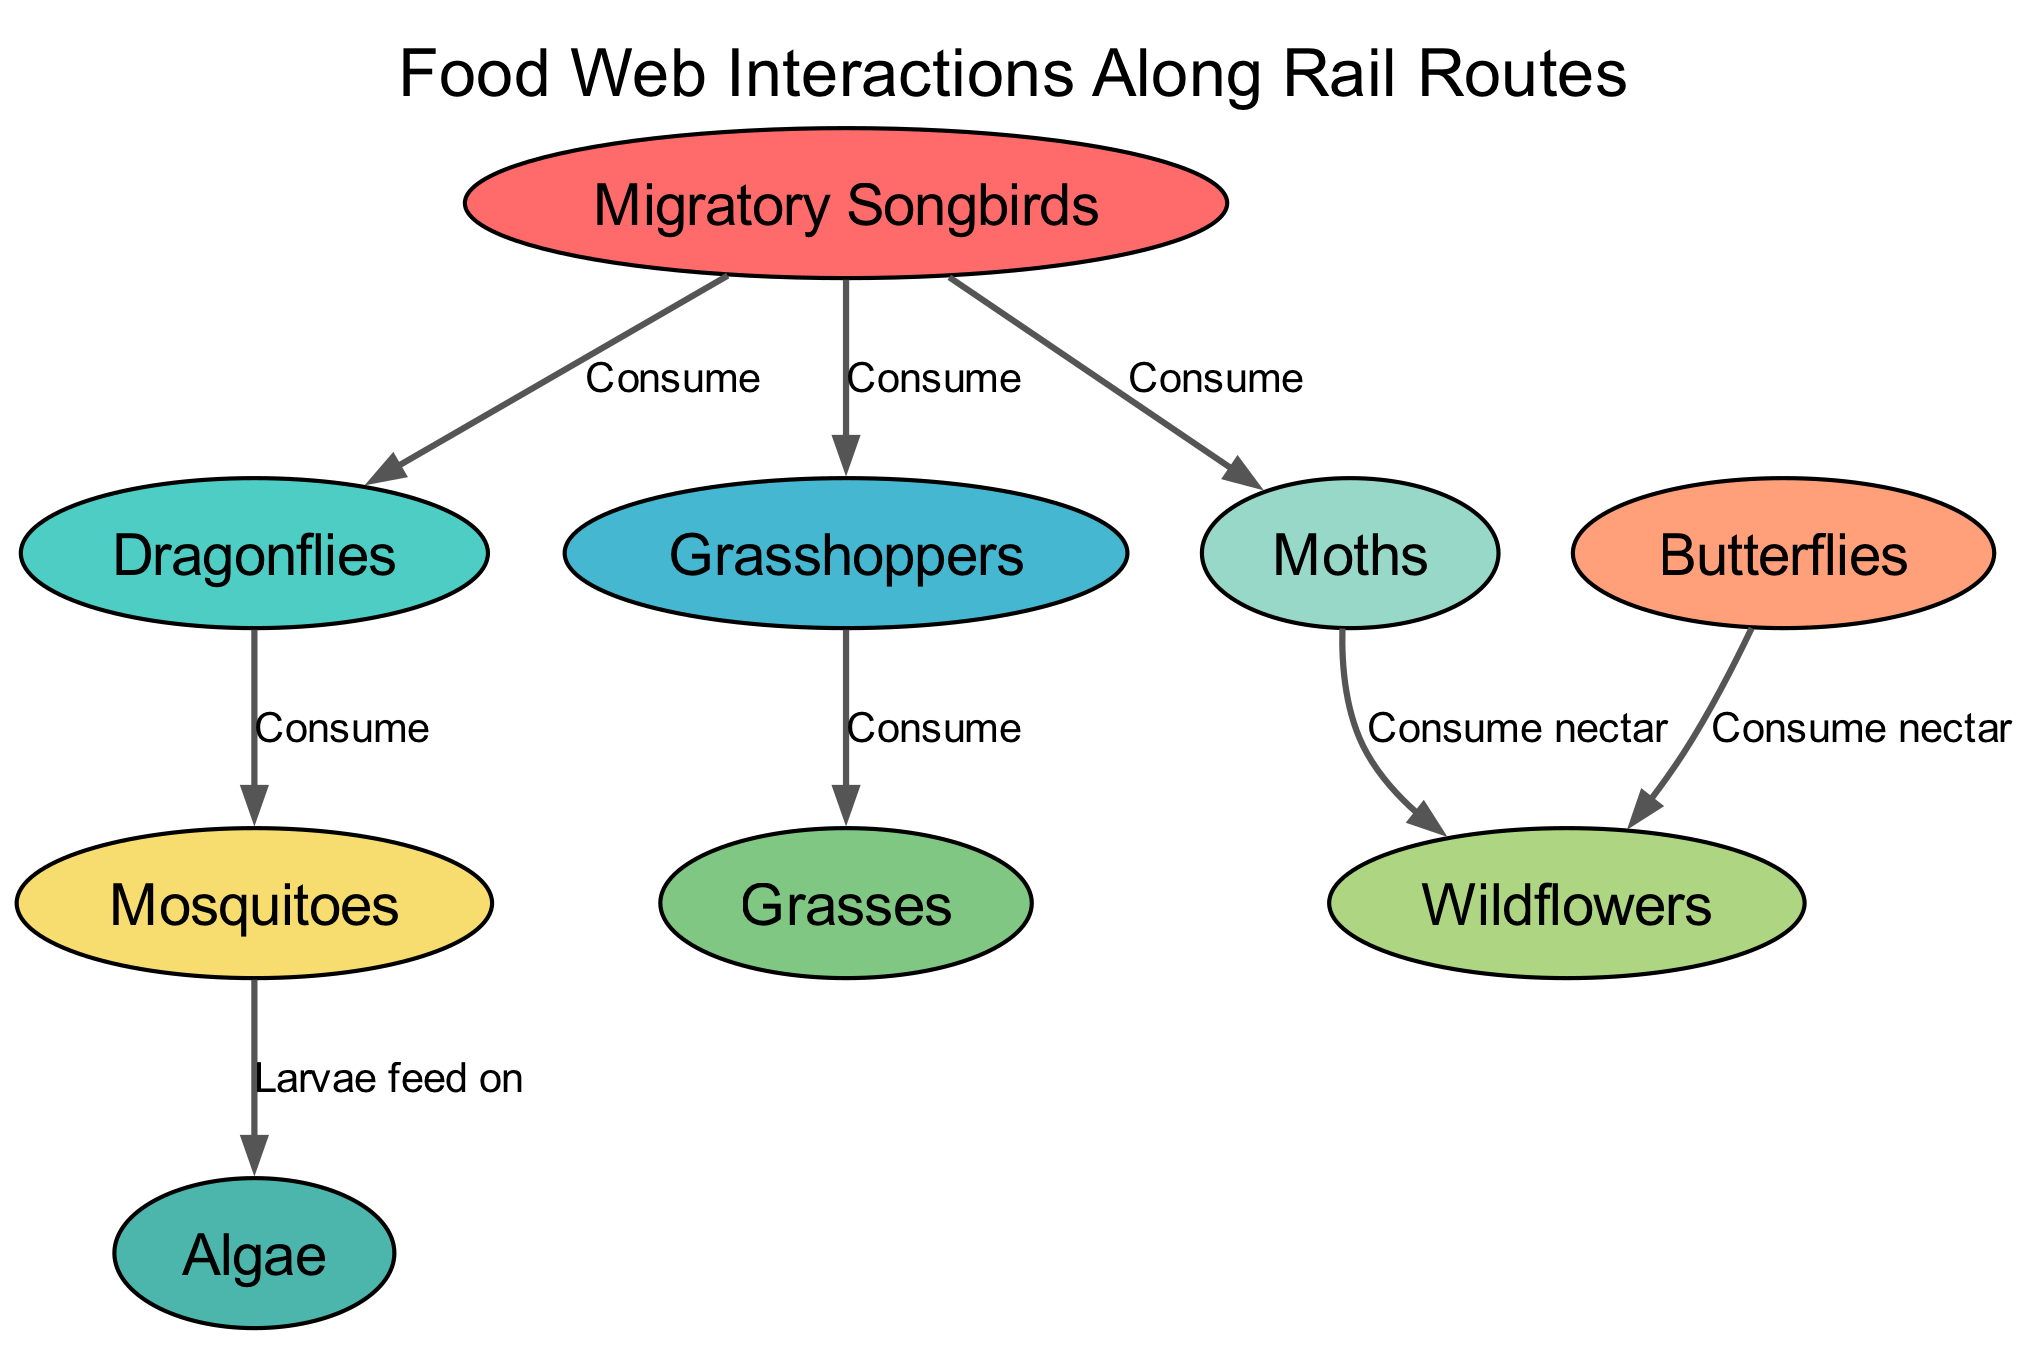What is the total number of nodes in the diagram? The nodes listed are: Migratory Songbirds, Dragonflies, Grasshoppers, Butterflies, Moths, Mosquitoes, Wildflowers, Grasses, and Algae. Counting these gives a total of 9 nodes.
Answer: 9 Which insect is consumed by Migratory Songbirds? The diagram shows three edges originating from Migratory Songbirds: one to Dragonflies, one to Grasshoppers, and one to Moths. Therefore, the insects consumed are Dragonflies, Grasshoppers, and Moths.
Answer: Dragonflies, Grasshoppers, Moths What do Butterflies consume? The diagram indicates that Butterflies have an edge directed towards Wildflowers, labeled "Consume nectar," which indicates their specific food source.
Answer: Wildflowers How many edges are represented in the diagram? The diagram visually shows the connections (edges) between the nodes. There are eight edges connecting the nodes in the data provided, which can be counted directly.
Answer: 8 Which organism is at the top of the food chain? The Migratory Songbirds are at the top, as they are consuming other organisms without being shown as being consumed themselves. This indicates their position in the food chain.
Answer: Migratory Songbirds What do Mosquito larvae feed on? According to the diagram, the Mosquitoes have a directed edge to Algae labeled "Larvae feed on," which identifies their food source during the larval stage.
Answer: Algae How many organisms consume nectar from Wildflowers? The diagram shows that both Butterflies and Moths have edges directed towards Wildflowers, both labeled as consuming nectar. This results in a total of two organisms that consume nectar from Wildflowers.
Answer: 2 What type of vegetation do Grasshoppers consume? The diagram shows an edge from Grasshoppers to Grasses labeled "Consume," indicating that Grasses are the vegetation that Grasshoppers feed on.
Answer: Grasses 